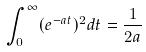<formula> <loc_0><loc_0><loc_500><loc_500>\int _ { 0 } ^ { \infty } ( e ^ { - a t } ) ^ { 2 } d t = \frac { 1 } { 2 a }</formula> 